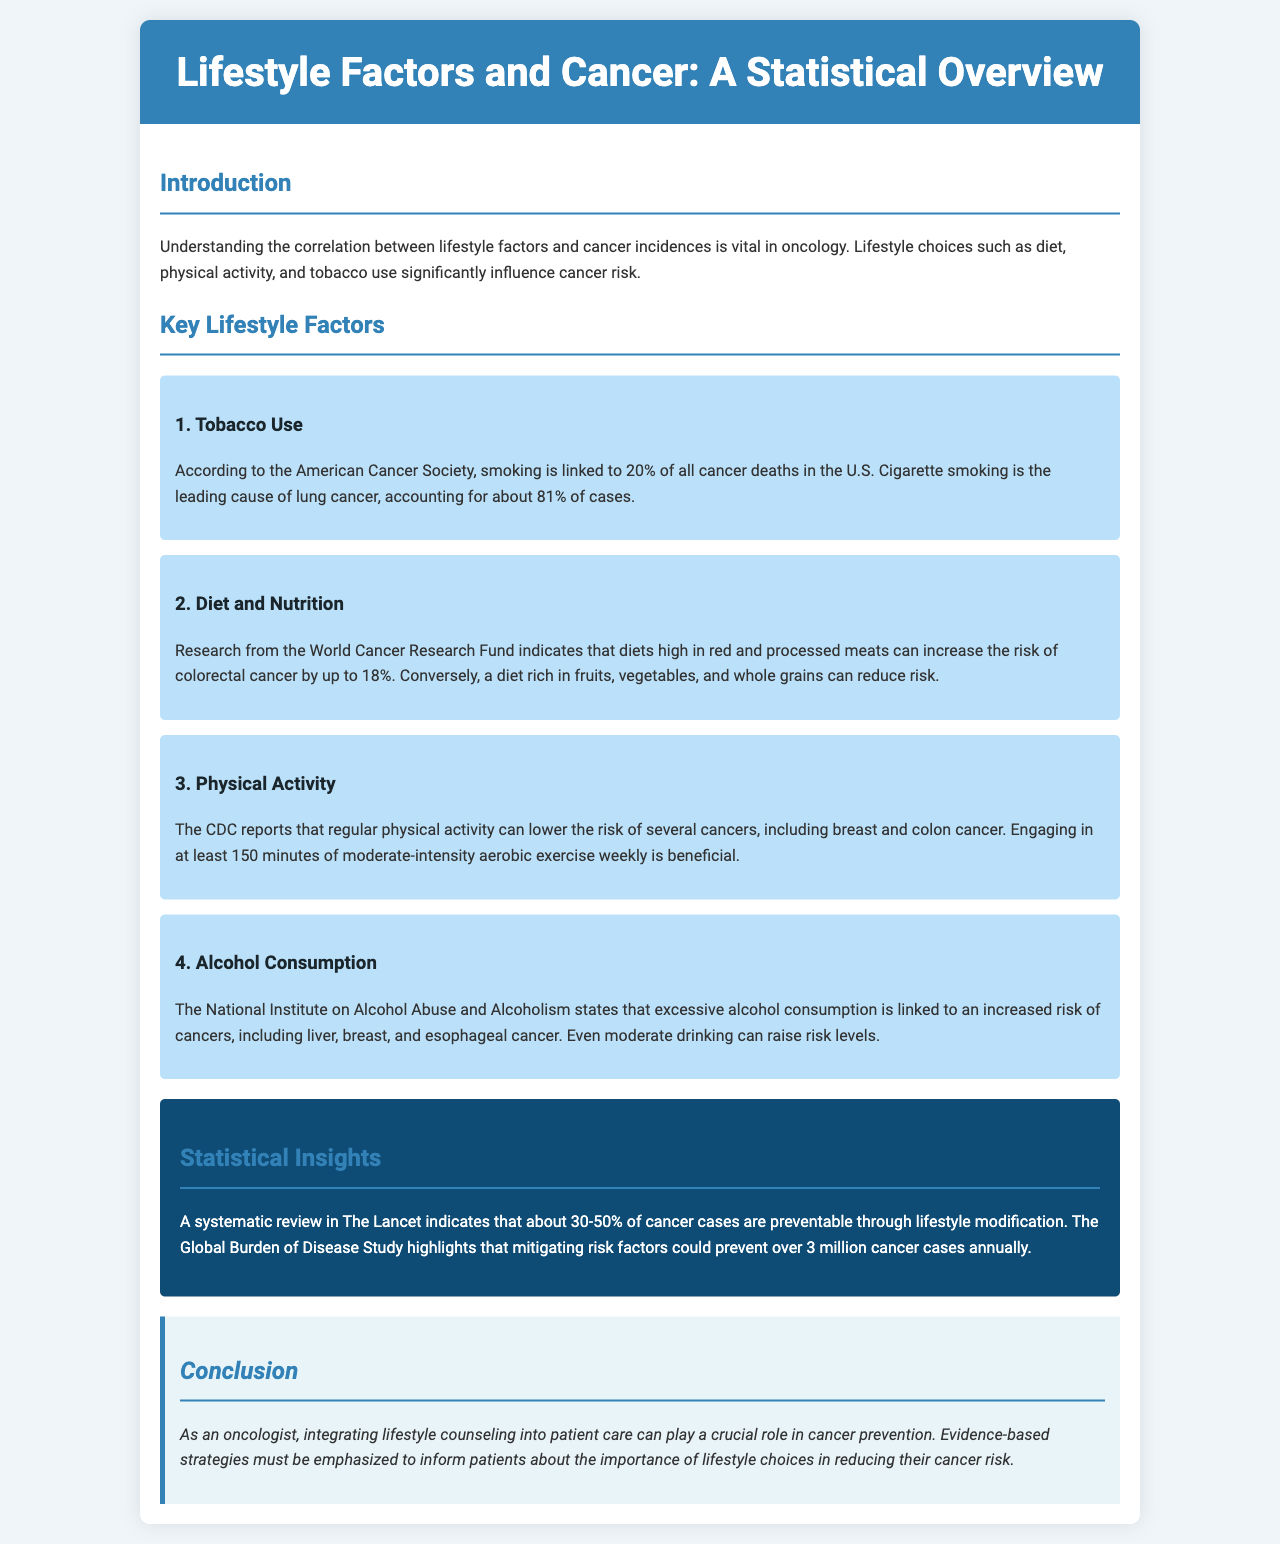what is the primary focus of the brochure? The brochure focuses on the correlation between lifestyle factors and cancer incidences.
Answer: correlation between lifestyle factors and cancer incidences how many percent of cancer deaths in the U.S. are linked to smoking? The document states that smoking is linked to 20% of all cancer deaths in the U.S.
Answer: 20% what is the risk increase for colorectal cancer with diets high in red and processed meats? The brochure indicates that such diets can increase the risk of colorectal cancer by up to 18%.
Answer: up to 18% how many minutes of moderate-intensity aerobic exercise are recommended weekly? The document advises engaging in at least 150 minutes of physical activity weekly.
Answer: 150 minutes which cancers are linked to excessive alcohol consumption? The brochure mentions liver, breast, and esophageal cancer as cancers linked to excessive alcohol consumption.
Answer: liver, breast, and esophageal what percentage of cancer cases are preventable through lifestyle modification according to The Lancet? The document states that about 30-50% of cancer cases are preventable.
Answer: 30-50% what is the annual estimate of cancer cases that could be prevented by mitigating risk factors? The Global Burden of Disease Study highlights that over 3 million cancer cases could be prevented annually.
Answer: over 3 million what is the unique role of oncologists mentioned in the brochure? The brochure highlights the importance of integrating lifestyle counseling into patient care.
Answer: integrating lifestyle counseling into patient care why is understanding lifestyle factors critical in oncology? Understanding lifestyle factors is vital in oncology for assessing cancer risk.
Answer: assessing cancer risk 